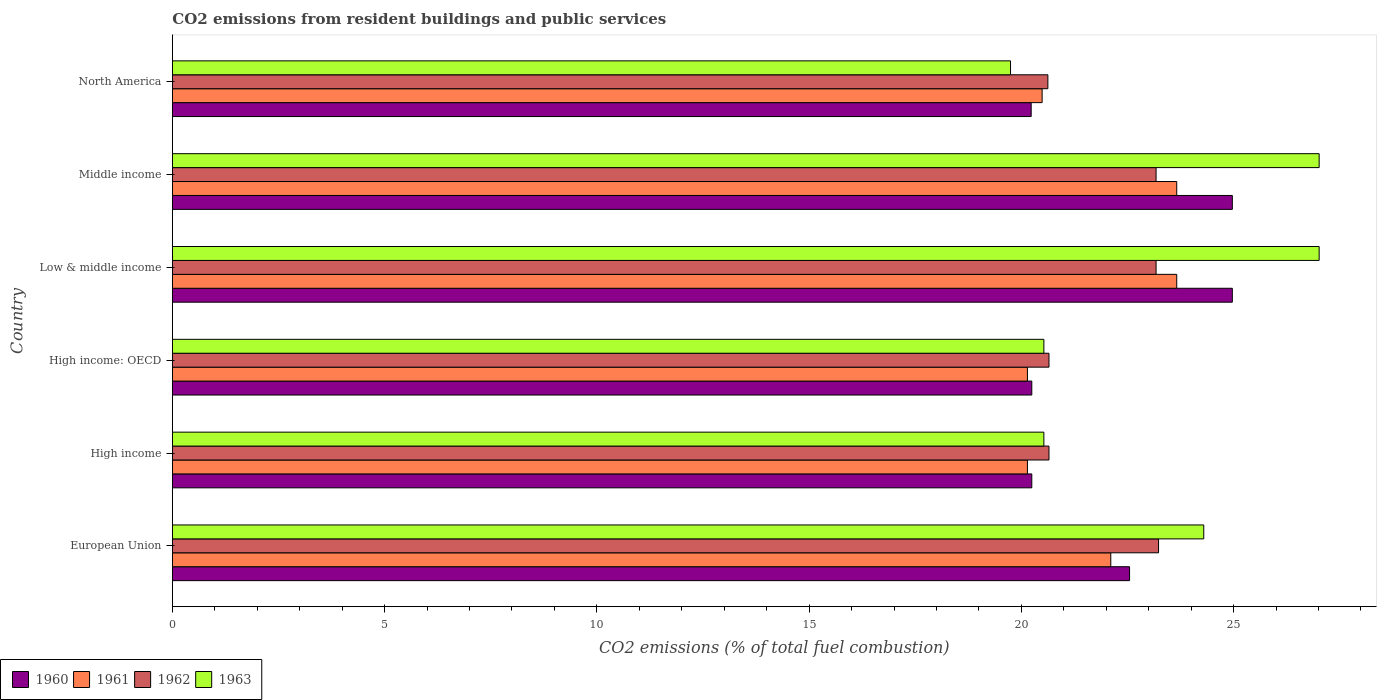How many groups of bars are there?
Make the answer very short. 6. Are the number of bars per tick equal to the number of legend labels?
Ensure brevity in your answer.  Yes. Are the number of bars on each tick of the Y-axis equal?
Provide a succinct answer. Yes. How many bars are there on the 1st tick from the top?
Provide a succinct answer. 4. What is the total CO2 emitted in 1962 in High income: OECD?
Offer a terse response. 20.65. Across all countries, what is the maximum total CO2 emitted in 1962?
Provide a short and direct response. 23.23. Across all countries, what is the minimum total CO2 emitted in 1960?
Your response must be concise. 20.23. What is the total total CO2 emitted in 1963 in the graph?
Give a very brief answer. 139.13. What is the difference between the total CO2 emitted in 1961 in European Union and that in North America?
Make the answer very short. 1.62. What is the difference between the total CO2 emitted in 1960 in North America and the total CO2 emitted in 1962 in Low & middle income?
Your answer should be compact. -2.94. What is the average total CO2 emitted in 1963 per country?
Offer a terse response. 23.19. What is the difference between the total CO2 emitted in 1960 and total CO2 emitted in 1961 in Low & middle income?
Keep it short and to the point. 1.31. Is the total CO2 emitted in 1960 in European Union less than that in High income?
Ensure brevity in your answer.  No. Is the difference between the total CO2 emitted in 1960 in European Union and High income greater than the difference between the total CO2 emitted in 1961 in European Union and High income?
Offer a very short reply. Yes. What is the difference between the highest and the second highest total CO2 emitted in 1960?
Ensure brevity in your answer.  0. What is the difference between the highest and the lowest total CO2 emitted in 1963?
Offer a very short reply. 7.27. Is it the case that in every country, the sum of the total CO2 emitted in 1961 and total CO2 emitted in 1963 is greater than the sum of total CO2 emitted in 1962 and total CO2 emitted in 1960?
Your answer should be very brief. No. What does the 1st bar from the bottom in Low & middle income represents?
Your answer should be very brief. 1960. How many bars are there?
Give a very brief answer. 24. Are all the bars in the graph horizontal?
Ensure brevity in your answer.  Yes. How many countries are there in the graph?
Your answer should be compact. 6. Are the values on the major ticks of X-axis written in scientific E-notation?
Ensure brevity in your answer.  No. How many legend labels are there?
Your response must be concise. 4. How are the legend labels stacked?
Provide a short and direct response. Horizontal. What is the title of the graph?
Keep it short and to the point. CO2 emissions from resident buildings and public services. Does "2001" appear as one of the legend labels in the graph?
Offer a terse response. No. What is the label or title of the X-axis?
Provide a short and direct response. CO2 emissions (% of total fuel combustion). What is the label or title of the Y-axis?
Make the answer very short. Country. What is the CO2 emissions (% of total fuel combustion) in 1960 in European Union?
Ensure brevity in your answer.  22.55. What is the CO2 emissions (% of total fuel combustion) of 1961 in European Union?
Your answer should be very brief. 22.11. What is the CO2 emissions (% of total fuel combustion) in 1962 in European Union?
Keep it short and to the point. 23.23. What is the CO2 emissions (% of total fuel combustion) of 1963 in European Union?
Offer a very short reply. 24.3. What is the CO2 emissions (% of total fuel combustion) in 1960 in High income?
Your answer should be compact. 20.25. What is the CO2 emissions (% of total fuel combustion) in 1961 in High income?
Make the answer very short. 20.14. What is the CO2 emissions (% of total fuel combustion) in 1962 in High income?
Your response must be concise. 20.65. What is the CO2 emissions (% of total fuel combustion) in 1963 in High income?
Give a very brief answer. 20.53. What is the CO2 emissions (% of total fuel combustion) in 1960 in High income: OECD?
Your answer should be very brief. 20.25. What is the CO2 emissions (% of total fuel combustion) in 1961 in High income: OECD?
Ensure brevity in your answer.  20.14. What is the CO2 emissions (% of total fuel combustion) in 1962 in High income: OECD?
Your answer should be compact. 20.65. What is the CO2 emissions (% of total fuel combustion) in 1963 in High income: OECD?
Your answer should be compact. 20.53. What is the CO2 emissions (% of total fuel combustion) of 1960 in Low & middle income?
Make the answer very short. 24.97. What is the CO2 emissions (% of total fuel combustion) of 1961 in Low & middle income?
Provide a succinct answer. 23.66. What is the CO2 emissions (% of total fuel combustion) of 1962 in Low & middle income?
Ensure brevity in your answer.  23.17. What is the CO2 emissions (% of total fuel combustion) in 1963 in Low & middle income?
Ensure brevity in your answer.  27.01. What is the CO2 emissions (% of total fuel combustion) of 1960 in Middle income?
Offer a terse response. 24.97. What is the CO2 emissions (% of total fuel combustion) in 1961 in Middle income?
Your answer should be compact. 23.66. What is the CO2 emissions (% of total fuel combustion) in 1962 in Middle income?
Offer a terse response. 23.17. What is the CO2 emissions (% of total fuel combustion) in 1963 in Middle income?
Your answer should be compact. 27.01. What is the CO2 emissions (% of total fuel combustion) in 1960 in North America?
Provide a short and direct response. 20.23. What is the CO2 emissions (% of total fuel combustion) in 1961 in North America?
Your response must be concise. 20.49. What is the CO2 emissions (% of total fuel combustion) of 1962 in North America?
Offer a terse response. 20.62. What is the CO2 emissions (% of total fuel combustion) in 1963 in North America?
Ensure brevity in your answer.  19.74. Across all countries, what is the maximum CO2 emissions (% of total fuel combustion) in 1960?
Ensure brevity in your answer.  24.97. Across all countries, what is the maximum CO2 emissions (% of total fuel combustion) of 1961?
Give a very brief answer. 23.66. Across all countries, what is the maximum CO2 emissions (% of total fuel combustion) of 1962?
Keep it short and to the point. 23.23. Across all countries, what is the maximum CO2 emissions (% of total fuel combustion) of 1963?
Offer a terse response. 27.01. Across all countries, what is the minimum CO2 emissions (% of total fuel combustion) of 1960?
Keep it short and to the point. 20.23. Across all countries, what is the minimum CO2 emissions (% of total fuel combustion) in 1961?
Your response must be concise. 20.14. Across all countries, what is the minimum CO2 emissions (% of total fuel combustion) in 1962?
Your answer should be very brief. 20.62. Across all countries, what is the minimum CO2 emissions (% of total fuel combustion) in 1963?
Your answer should be very brief. 19.74. What is the total CO2 emissions (% of total fuel combustion) in 1960 in the graph?
Keep it short and to the point. 133.21. What is the total CO2 emissions (% of total fuel combustion) in 1961 in the graph?
Ensure brevity in your answer.  130.2. What is the total CO2 emissions (% of total fuel combustion) in 1962 in the graph?
Make the answer very short. 131.5. What is the total CO2 emissions (% of total fuel combustion) in 1963 in the graph?
Offer a terse response. 139.13. What is the difference between the CO2 emissions (% of total fuel combustion) in 1960 in European Union and that in High income?
Your response must be concise. 2.3. What is the difference between the CO2 emissions (% of total fuel combustion) in 1961 in European Union and that in High income?
Offer a terse response. 1.96. What is the difference between the CO2 emissions (% of total fuel combustion) in 1962 in European Union and that in High income?
Offer a terse response. 2.58. What is the difference between the CO2 emissions (% of total fuel combustion) in 1963 in European Union and that in High income?
Offer a very short reply. 3.77. What is the difference between the CO2 emissions (% of total fuel combustion) of 1960 in European Union and that in High income: OECD?
Your answer should be compact. 2.3. What is the difference between the CO2 emissions (% of total fuel combustion) in 1961 in European Union and that in High income: OECD?
Your response must be concise. 1.96. What is the difference between the CO2 emissions (% of total fuel combustion) in 1962 in European Union and that in High income: OECD?
Your answer should be compact. 2.58. What is the difference between the CO2 emissions (% of total fuel combustion) in 1963 in European Union and that in High income: OECD?
Offer a very short reply. 3.77. What is the difference between the CO2 emissions (% of total fuel combustion) of 1960 in European Union and that in Low & middle income?
Your response must be concise. -2.42. What is the difference between the CO2 emissions (% of total fuel combustion) of 1961 in European Union and that in Low & middle income?
Provide a short and direct response. -1.55. What is the difference between the CO2 emissions (% of total fuel combustion) of 1962 in European Union and that in Low & middle income?
Your answer should be very brief. 0.06. What is the difference between the CO2 emissions (% of total fuel combustion) in 1963 in European Union and that in Low & middle income?
Your answer should be very brief. -2.72. What is the difference between the CO2 emissions (% of total fuel combustion) of 1960 in European Union and that in Middle income?
Your response must be concise. -2.42. What is the difference between the CO2 emissions (% of total fuel combustion) of 1961 in European Union and that in Middle income?
Your answer should be compact. -1.55. What is the difference between the CO2 emissions (% of total fuel combustion) in 1962 in European Union and that in Middle income?
Offer a terse response. 0.06. What is the difference between the CO2 emissions (% of total fuel combustion) in 1963 in European Union and that in Middle income?
Provide a short and direct response. -2.72. What is the difference between the CO2 emissions (% of total fuel combustion) in 1960 in European Union and that in North America?
Offer a terse response. 2.32. What is the difference between the CO2 emissions (% of total fuel combustion) in 1961 in European Union and that in North America?
Make the answer very short. 1.62. What is the difference between the CO2 emissions (% of total fuel combustion) of 1962 in European Union and that in North America?
Offer a terse response. 2.61. What is the difference between the CO2 emissions (% of total fuel combustion) of 1963 in European Union and that in North America?
Provide a short and direct response. 4.55. What is the difference between the CO2 emissions (% of total fuel combustion) of 1960 in High income and that in High income: OECD?
Provide a short and direct response. 0. What is the difference between the CO2 emissions (% of total fuel combustion) in 1960 in High income and that in Low & middle income?
Provide a short and direct response. -4.72. What is the difference between the CO2 emissions (% of total fuel combustion) in 1961 in High income and that in Low & middle income?
Ensure brevity in your answer.  -3.52. What is the difference between the CO2 emissions (% of total fuel combustion) of 1962 in High income and that in Low & middle income?
Provide a short and direct response. -2.52. What is the difference between the CO2 emissions (% of total fuel combustion) of 1963 in High income and that in Low & middle income?
Provide a short and direct response. -6.48. What is the difference between the CO2 emissions (% of total fuel combustion) in 1960 in High income and that in Middle income?
Make the answer very short. -4.72. What is the difference between the CO2 emissions (% of total fuel combustion) of 1961 in High income and that in Middle income?
Make the answer very short. -3.52. What is the difference between the CO2 emissions (% of total fuel combustion) of 1962 in High income and that in Middle income?
Your response must be concise. -2.52. What is the difference between the CO2 emissions (% of total fuel combustion) in 1963 in High income and that in Middle income?
Your answer should be compact. -6.48. What is the difference between the CO2 emissions (% of total fuel combustion) in 1960 in High income and that in North America?
Your answer should be compact. 0.01. What is the difference between the CO2 emissions (% of total fuel combustion) of 1961 in High income and that in North America?
Offer a terse response. -0.35. What is the difference between the CO2 emissions (% of total fuel combustion) of 1962 in High income and that in North America?
Provide a short and direct response. 0.03. What is the difference between the CO2 emissions (% of total fuel combustion) of 1963 in High income and that in North America?
Provide a succinct answer. 0.79. What is the difference between the CO2 emissions (% of total fuel combustion) of 1960 in High income: OECD and that in Low & middle income?
Your answer should be very brief. -4.72. What is the difference between the CO2 emissions (% of total fuel combustion) of 1961 in High income: OECD and that in Low & middle income?
Ensure brevity in your answer.  -3.52. What is the difference between the CO2 emissions (% of total fuel combustion) in 1962 in High income: OECD and that in Low & middle income?
Provide a short and direct response. -2.52. What is the difference between the CO2 emissions (% of total fuel combustion) in 1963 in High income: OECD and that in Low & middle income?
Your response must be concise. -6.48. What is the difference between the CO2 emissions (% of total fuel combustion) in 1960 in High income: OECD and that in Middle income?
Ensure brevity in your answer.  -4.72. What is the difference between the CO2 emissions (% of total fuel combustion) in 1961 in High income: OECD and that in Middle income?
Your answer should be very brief. -3.52. What is the difference between the CO2 emissions (% of total fuel combustion) in 1962 in High income: OECD and that in Middle income?
Your answer should be compact. -2.52. What is the difference between the CO2 emissions (% of total fuel combustion) in 1963 in High income: OECD and that in Middle income?
Provide a succinct answer. -6.48. What is the difference between the CO2 emissions (% of total fuel combustion) in 1960 in High income: OECD and that in North America?
Your answer should be compact. 0.01. What is the difference between the CO2 emissions (% of total fuel combustion) of 1961 in High income: OECD and that in North America?
Your response must be concise. -0.35. What is the difference between the CO2 emissions (% of total fuel combustion) of 1962 in High income: OECD and that in North America?
Offer a very short reply. 0.03. What is the difference between the CO2 emissions (% of total fuel combustion) of 1963 in High income: OECD and that in North America?
Your response must be concise. 0.79. What is the difference between the CO2 emissions (% of total fuel combustion) in 1960 in Low & middle income and that in Middle income?
Your response must be concise. 0. What is the difference between the CO2 emissions (% of total fuel combustion) in 1960 in Low & middle income and that in North America?
Make the answer very short. 4.74. What is the difference between the CO2 emissions (% of total fuel combustion) in 1961 in Low & middle income and that in North America?
Offer a terse response. 3.17. What is the difference between the CO2 emissions (% of total fuel combustion) in 1962 in Low & middle income and that in North America?
Offer a very short reply. 2.55. What is the difference between the CO2 emissions (% of total fuel combustion) in 1963 in Low & middle income and that in North America?
Your response must be concise. 7.27. What is the difference between the CO2 emissions (% of total fuel combustion) of 1960 in Middle income and that in North America?
Make the answer very short. 4.74. What is the difference between the CO2 emissions (% of total fuel combustion) of 1961 in Middle income and that in North America?
Offer a terse response. 3.17. What is the difference between the CO2 emissions (% of total fuel combustion) in 1962 in Middle income and that in North America?
Your response must be concise. 2.55. What is the difference between the CO2 emissions (% of total fuel combustion) of 1963 in Middle income and that in North America?
Give a very brief answer. 7.27. What is the difference between the CO2 emissions (% of total fuel combustion) in 1960 in European Union and the CO2 emissions (% of total fuel combustion) in 1961 in High income?
Your response must be concise. 2.41. What is the difference between the CO2 emissions (% of total fuel combustion) of 1960 in European Union and the CO2 emissions (% of total fuel combustion) of 1962 in High income?
Provide a succinct answer. 1.9. What is the difference between the CO2 emissions (% of total fuel combustion) in 1960 in European Union and the CO2 emissions (% of total fuel combustion) in 1963 in High income?
Your response must be concise. 2.02. What is the difference between the CO2 emissions (% of total fuel combustion) in 1961 in European Union and the CO2 emissions (% of total fuel combustion) in 1962 in High income?
Provide a short and direct response. 1.46. What is the difference between the CO2 emissions (% of total fuel combustion) in 1961 in European Union and the CO2 emissions (% of total fuel combustion) in 1963 in High income?
Give a very brief answer. 1.58. What is the difference between the CO2 emissions (% of total fuel combustion) of 1962 in European Union and the CO2 emissions (% of total fuel combustion) of 1963 in High income?
Offer a very short reply. 2.7. What is the difference between the CO2 emissions (% of total fuel combustion) in 1960 in European Union and the CO2 emissions (% of total fuel combustion) in 1961 in High income: OECD?
Make the answer very short. 2.41. What is the difference between the CO2 emissions (% of total fuel combustion) of 1960 in European Union and the CO2 emissions (% of total fuel combustion) of 1962 in High income: OECD?
Your answer should be compact. 1.9. What is the difference between the CO2 emissions (% of total fuel combustion) of 1960 in European Union and the CO2 emissions (% of total fuel combustion) of 1963 in High income: OECD?
Provide a succinct answer. 2.02. What is the difference between the CO2 emissions (% of total fuel combustion) of 1961 in European Union and the CO2 emissions (% of total fuel combustion) of 1962 in High income: OECD?
Your response must be concise. 1.46. What is the difference between the CO2 emissions (% of total fuel combustion) of 1961 in European Union and the CO2 emissions (% of total fuel combustion) of 1963 in High income: OECD?
Provide a succinct answer. 1.58. What is the difference between the CO2 emissions (% of total fuel combustion) of 1962 in European Union and the CO2 emissions (% of total fuel combustion) of 1963 in High income: OECD?
Make the answer very short. 2.7. What is the difference between the CO2 emissions (% of total fuel combustion) in 1960 in European Union and the CO2 emissions (% of total fuel combustion) in 1961 in Low & middle income?
Your answer should be compact. -1.11. What is the difference between the CO2 emissions (% of total fuel combustion) in 1960 in European Union and the CO2 emissions (% of total fuel combustion) in 1962 in Low & middle income?
Your answer should be compact. -0.62. What is the difference between the CO2 emissions (% of total fuel combustion) of 1960 in European Union and the CO2 emissions (% of total fuel combustion) of 1963 in Low & middle income?
Offer a terse response. -4.47. What is the difference between the CO2 emissions (% of total fuel combustion) of 1961 in European Union and the CO2 emissions (% of total fuel combustion) of 1962 in Low & middle income?
Ensure brevity in your answer.  -1.07. What is the difference between the CO2 emissions (% of total fuel combustion) in 1961 in European Union and the CO2 emissions (% of total fuel combustion) in 1963 in Low & middle income?
Provide a succinct answer. -4.91. What is the difference between the CO2 emissions (% of total fuel combustion) of 1962 in European Union and the CO2 emissions (% of total fuel combustion) of 1963 in Low & middle income?
Give a very brief answer. -3.78. What is the difference between the CO2 emissions (% of total fuel combustion) in 1960 in European Union and the CO2 emissions (% of total fuel combustion) in 1961 in Middle income?
Your answer should be very brief. -1.11. What is the difference between the CO2 emissions (% of total fuel combustion) in 1960 in European Union and the CO2 emissions (% of total fuel combustion) in 1962 in Middle income?
Your answer should be very brief. -0.62. What is the difference between the CO2 emissions (% of total fuel combustion) in 1960 in European Union and the CO2 emissions (% of total fuel combustion) in 1963 in Middle income?
Provide a short and direct response. -4.47. What is the difference between the CO2 emissions (% of total fuel combustion) of 1961 in European Union and the CO2 emissions (% of total fuel combustion) of 1962 in Middle income?
Offer a terse response. -1.07. What is the difference between the CO2 emissions (% of total fuel combustion) of 1961 in European Union and the CO2 emissions (% of total fuel combustion) of 1963 in Middle income?
Provide a succinct answer. -4.91. What is the difference between the CO2 emissions (% of total fuel combustion) in 1962 in European Union and the CO2 emissions (% of total fuel combustion) in 1963 in Middle income?
Offer a very short reply. -3.78. What is the difference between the CO2 emissions (% of total fuel combustion) in 1960 in European Union and the CO2 emissions (% of total fuel combustion) in 1961 in North America?
Give a very brief answer. 2.06. What is the difference between the CO2 emissions (% of total fuel combustion) of 1960 in European Union and the CO2 emissions (% of total fuel combustion) of 1962 in North America?
Ensure brevity in your answer.  1.92. What is the difference between the CO2 emissions (% of total fuel combustion) in 1960 in European Union and the CO2 emissions (% of total fuel combustion) in 1963 in North America?
Your response must be concise. 2.8. What is the difference between the CO2 emissions (% of total fuel combustion) in 1961 in European Union and the CO2 emissions (% of total fuel combustion) in 1962 in North America?
Offer a very short reply. 1.48. What is the difference between the CO2 emissions (% of total fuel combustion) of 1961 in European Union and the CO2 emissions (% of total fuel combustion) of 1963 in North America?
Offer a terse response. 2.36. What is the difference between the CO2 emissions (% of total fuel combustion) of 1962 in European Union and the CO2 emissions (% of total fuel combustion) of 1963 in North America?
Your answer should be compact. 3.49. What is the difference between the CO2 emissions (% of total fuel combustion) in 1960 in High income and the CO2 emissions (% of total fuel combustion) in 1961 in High income: OECD?
Ensure brevity in your answer.  0.1. What is the difference between the CO2 emissions (% of total fuel combustion) of 1960 in High income and the CO2 emissions (% of total fuel combustion) of 1962 in High income: OECD?
Your answer should be very brief. -0.4. What is the difference between the CO2 emissions (% of total fuel combustion) of 1960 in High income and the CO2 emissions (% of total fuel combustion) of 1963 in High income: OECD?
Your answer should be very brief. -0.28. What is the difference between the CO2 emissions (% of total fuel combustion) in 1961 in High income and the CO2 emissions (% of total fuel combustion) in 1962 in High income: OECD?
Make the answer very short. -0.51. What is the difference between the CO2 emissions (% of total fuel combustion) in 1961 in High income and the CO2 emissions (% of total fuel combustion) in 1963 in High income: OECD?
Offer a very short reply. -0.39. What is the difference between the CO2 emissions (% of total fuel combustion) of 1962 in High income and the CO2 emissions (% of total fuel combustion) of 1963 in High income: OECD?
Provide a succinct answer. 0.12. What is the difference between the CO2 emissions (% of total fuel combustion) in 1960 in High income and the CO2 emissions (% of total fuel combustion) in 1961 in Low & middle income?
Provide a succinct answer. -3.41. What is the difference between the CO2 emissions (% of total fuel combustion) in 1960 in High income and the CO2 emissions (% of total fuel combustion) in 1962 in Low & middle income?
Make the answer very short. -2.93. What is the difference between the CO2 emissions (% of total fuel combustion) of 1960 in High income and the CO2 emissions (% of total fuel combustion) of 1963 in Low & middle income?
Offer a terse response. -6.77. What is the difference between the CO2 emissions (% of total fuel combustion) of 1961 in High income and the CO2 emissions (% of total fuel combustion) of 1962 in Low & middle income?
Give a very brief answer. -3.03. What is the difference between the CO2 emissions (% of total fuel combustion) of 1961 in High income and the CO2 emissions (% of total fuel combustion) of 1963 in Low & middle income?
Offer a terse response. -6.87. What is the difference between the CO2 emissions (% of total fuel combustion) in 1962 in High income and the CO2 emissions (% of total fuel combustion) in 1963 in Low & middle income?
Make the answer very short. -6.36. What is the difference between the CO2 emissions (% of total fuel combustion) in 1960 in High income and the CO2 emissions (% of total fuel combustion) in 1961 in Middle income?
Ensure brevity in your answer.  -3.41. What is the difference between the CO2 emissions (% of total fuel combustion) in 1960 in High income and the CO2 emissions (% of total fuel combustion) in 1962 in Middle income?
Your response must be concise. -2.93. What is the difference between the CO2 emissions (% of total fuel combustion) of 1960 in High income and the CO2 emissions (% of total fuel combustion) of 1963 in Middle income?
Offer a terse response. -6.77. What is the difference between the CO2 emissions (% of total fuel combustion) of 1961 in High income and the CO2 emissions (% of total fuel combustion) of 1962 in Middle income?
Offer a terse response. -3.03. What is the difference between the CO2 emissions (% of total fuel combustion) of 1961 in High income and the CO2 emissions (% of total fuel combustion) of 1963 in Middle income?
Give a very brief answer. -6.87. What is the difference between the CO2 emissions (% of total fuel combustion) in 1962 in High income and the CO2 emissions (% of total fuel combustion) in 1963 in Middle income?
Provide a short and direct response. -6.36. What is the difference between the CO2 emissions (% of total fuel combustion) of 1960 in High income and the CO2 emissions (% of total fuel combustion) of 1961 in North America?
Your answer should be compact. -0.24. What is the difference between the CO2 emissions (% of total fuel combustion) in 1960 in High income and the CO2 emissions (% of total fuel combustion) in 1962 in North America?
Provide a succinct answer. -0.38. What is the difference between the CO2 emissions (% of total fuel combustion) of 1960 in High income and the CO2 emissions (% of total fuel combustion) of 1963 in North America?
Give a very brief answer. 0.5. What is the difference between the CO2 emissions (% of total fuel combustion) in 1961 in High income and the CO2 emissions (% of total fuel combustion) in 1962 in North America?
Give a very brief answer. -0.48. What is the difference between the CO2 emissions (% of total fuel combustion) of 1961 in High income and the CO2 emissions (% of total fuel combustion) of 1963 in North America?
Provide a short and direct response. 0.4. What is the difference between the CO2 emissions (% of total fuel combustion) of 1962 in High income and the CO2 emissions (% of total fuel combustion) of 1963 in North America?
Your response must be concise. 0.91. What is the difference between the CO2 emissions (% of total fuel combustion) in 1960 in High income: OECD and the CO2 emissions (% of total fuel combustion) in 1961 in Low & middle income?
Keep it short and to the point. -3.41. What is the difference between the CO2 emissions (% of total fuel combustion) of 1960 in High income: OECD and the CO2 emissions (% of total fuel combustion) of 1962 in Low & middle income?
Provide a short and direct response. -2.93. What is the difference between the CO2 emissions (% of total fuel combustion) in 1960 in High income: OECD and the CO2 emissions (% of total fuel combustion) in 1963 in Low & middle income?
Your answer should be compact. -6.77. What is the difference between the CO2 emissions (% of total fuel combustion) in 1961 in High income: OECD and the CO2 emissions (% of total fuel combustion) in 1962 in Low & middle income?
Your answer should be compact. -3.03. What is the difference between the CO2 emissions (% of total fuel combustion) in 1961 in High income: OECD and the CO2 emissions (% of total fuel combustion) in 1963 in Low & middle income?
Offer a terse response. -6.87. What is the difference between the CO2 emissions (% of total fuel combustion) in 1962 in High income: OECD and the CO2 emissions (% of total fuel combustion) in 1963 in Low & middle income?
Provide a succinct answer. -6.36. What is the difference between the CO2 emissions (% of total fuel combustion) in 1960 in High income: OECD and the CO2 emissions (% of total fuel combustion) in 1961 in Middle income?
Your answer should be compact. -3.41. What is the difference between the CO2 emissions (% of total fuel combustion) in 1960 in High income: OECD and the CO2 emissions (% of total fuel combustion) in 1962 in Middle income?
Offer a very short reply. -2.93. What is the difference between the CO2 emissions (% of total fuel combustion) of 1960 in High income: OECD and the CO2 emissions (% of total fuel combustion) of 1963 in Middle income?
Your response must be concise. -6.77. What is the difference between the CO2 emissions (% of total fuel combustion) in 1961 in High income: OECD and the CO2 emissions (% of total fuel combustion) in 1962 in Middle income?
Your answer should be very brief. -3.03. What is the difference between the CO2 emissions (% of total fuel combustion) of 1961 in High income: OECD and the CO2 emissions (% of total fuel combustion) of 1963 in Middle income?
Provide a succinct answer. -6.87. What is the difference between the CO2 emissions (% of total fuel combustion) of 1962 in High income: OECD and the CO2 emissions (% of total fuel combustion) of 1963 in Middle income?
Provide a succinct answer. -6.36. What is the difference between the CO2 emissions (% of total fuel combustion) of 1960 in High income: OECD and the CO2 emissions (% of total fuel combustion) of 1961 in North America?
Offer a terse response. -0.24. What is the difference between the CO2 emissions (% of total fuel combustion) in 1960 in High income: OECD and the CO2 emissions (% of total fuel combustion) in 1962 in North America?
Offer a terse response. -0.38. What is the difference between the CO2 emissions (% of total fuel combustion) of 1960 in High income: OECD and the CO2 emissions (% of total fuel combustion) of 1963 in North America?
Keep it short and to the point. 0.5. What is the difference between the CO2 emissions (% of total fuel combustion) in 1961 in High income: OECD and the CO2 emissions (% of total fuel combustion) in 1962 in North America?
Your response must be concise. -0.48. What is the difference between the CO2 emissions (% of total fuel combustion) of 1961 in High income: OECD and the CO2 emissions (% of total fuel combustion) of 1963 in North America?
Your response must be concise. 0.4. What is the difference between the CO2 emissions (% of total fuel combustion) in 1962 in High income: OECD and the CO2 emissions (% of total fuel combustion) in 1963 in North America?
Offer a very short reply. 0.91. What is the difference between the CO2 emissions (% of total fuel combustion) of 1960 in Low & middle income and the CO2 emissions (% of total fuel combustion) of 1961 in Middle income?
Keep it short and to the point. 1.31. What is the difference between the CO2 emissions (% of total fuel combustion) in 1960 in Low & middle income and the CO2 emissions (% of total fuel combustion) in 1962 in Middle income?
Ensure brevity in your answer.  1.8. What is the difference between the CO2 emissions (% of total fuel combustion) of 1960 in Low & middle income and the CO2 emissions (% of total fuel combustion) of 1963 in Middle income?
Provide a short and direct response. -2.05. What is the difference between the CO2 emissions (% of total fuel combustion) of 1961 in Low & middle income and the CO2 emissions (% of total fuel combustion) of 1962 in Middle income?
Provide a succinct answer. 0.49. What is the difference between the CO2 emissions (% of total fuel combustion) of 1961 in Low & middle income and the CO2 emissions (% of total fuel combustion) of 1963 in Middle income?
Your response must be concise. -3.35. What is the difference between the CO2 emissions (% of total fuel combustion) in 1962 in Low & middle income and the CO2 emissions (% of total fuel combustion) in 1963 in Middle income?
Your answer should be very brief. -3.84. What is the difference between the CO2 emissions (% of total fuel combustion) in 1960 in Low & middle income and the CO2 emissions (% of total fuel combustion) in 1961 in North America?
Your answer should be compact. 4.48. What is the difference between the CO2 emissions (% of total fuel combustion) in 1960 in Low & middle income and the CO2 emissions (% of total fuel combustion) in 1962 in North America?
Offer a very short reply. 4.35. What is the difference between the CO2 emissions (% of total fuel combustion) of 1960 in Low & middle income and the CO2 emissions (% of total fuel combustion) of 1963 in North America?
Make the answer very short. 5.22. What is the difference between the CO2 emissions (% of total fuel combustion) of 1961 in Low & middle income and the CO2 emissions (% of total fuel combustion) of 1962 in North America?
Offer a terse response. 3.04. What is the difference between the CO2 emissions (% of total fuel combustion) in 1961 in Low & middle income and the CO2 emissions (% of total fuel combustion) in 1963 in North America?
Provide a succinct answer. 3.92. What is the difference between the CO2 emissions (% of total fuel combustion) in 1962 in Low & middle income and the CO2 emissions (% of total fuel combustion) in 1963 in North America?
Your response must be concise. 3.43. What is the difference between the CO2 emissions (% of total fuel combustion) in 1960 in Middle income and the CO2 emissions (% of total fuel combustion) in 1961 in North America?
Your response must be concise. 4.48. What is the difference between the CO2 emissions (% of total fuel combustion) in 1960 in Middle income and the CO2 emissions (% of total fuel combustion) in 1962 in North America?
Your answer should be very brief. 4.35. What is the difference between the CO2 emissions (% of total fuel combustion) of 1960 in Middle income and the CO2 emissions (% of total fuel combustion) of 1963 in North America?
Make the answer very short. 5.22. What is the difference between the CO2 emissions (% of total fuel combustion) in 1961 in Middle income and the CO2 emissions (% of total fuel combustion) in 1962 in North America?
Ensure brevity in your answer.  3.04. What is the difference between the CO2 emissions (% of total fuel combustion) of 1961 in Middle income and the CO2 emissions (% of total fuel combustion) of 1963 in North America?
Make the answer very short. 3.92. What is the difference between the CO2 emissions (% of total fuel combustion) in 1962 in Middle income and the CO2 emissions (% of total fuel combustion) in 1963 in North America?
Keep it short and to the point. 3.43. What is the average CO2 emissions (% of total fuel combustion) of 1960 per country?
Your response must be concise. 22.2. What is the average CO2 emissions (% of total fuel combustion) in 1961 per country?
Offer a very short reply. 21.7. What is the average CO2 emissions (% of total fuel combustion) in 1962 per country?
Ensure brevity in your answer.  21.92. What is the average CO2 emissions (% of total fuel combustion) in 1963 per country?
Your answer should be very brief. 23.19. What is the difference between the CO2 emissions (% of total fuel combustion) in 1960 and CO2 emissions (% of total fuel combustion) in 1961 in European Union?
Your response must be concise. 0.44. What is the difference between the CO2 emissions (% of total fuel combustion) in 1960 and CO2 emissions (% of total fuel combustion) in 1962 in European Union?
Provide a succinct answer. -0.68. What is the difference between the CO2 emissions (% of total fuel combustion) in 1960 and CO2 emissions (% of total fuel combustion) in 1963 in European Union?
Your answer should be very brief. -1.75. What is the difference between the CO2 emissions (% of total fuel combustion) of 1961 and CO2 emissions (% of total fuel combustion) of 1962 in European Union?
Give a very brief answer. -1.13. What is the difference between the CO2 emissions (% of total fuel combustion) in 1961 and CO2 emissions (% of total fuel combustion) in 1963 in European Union?
Make the answer very short. -2.19. What is the difference between the CO2 emissions (% of total fuel combustion) of 1962 and CO2 emissions (% of total fuel combustion) of 1963 in European Union?
Your answer should be very brief. -1.07. What is the difference between the CO2 emissions (% of total fuel combustion) of 1960 and CO2 emissions (% of total fuel combustion) of 1961 in High income?
Provide a short and direct response. 0.1. What is the difference between the CO2 emissions (% of total fuel combustion) in 1960 and CO2 emissions (% of total fuel combustion) in 1962 in High income?
Provide a short and direct response. -0.4. What is the difference between the CO2 emissions (% of total fuel combustion) in 1960 and CO2 emissions (% of total fuel combustion) in 1963 in High income?
Ensure brevity in your answer.  -0.28. What is the difference between the CO2 emissions (% of total fuel combustion) in 1961 and CO2 emissions (% of total fuel combustion) in 1962 in High income?
Offer a very short reply. -0.51. What is the difference between the CO2 emissions (% of total fuel combustion) of 1961 and CO2 emissions (% of total fuel combustion) of 1963 in High income?
Keep it short and to the point. -0.39. What is the difference between the CO2 emissions (% of total fuel combustion) in 1962 and CO2 emissions (% of total fuel combustion) in 1963 in High income?
Provide a succinct answer. 0.12. What is the difference between the CO2 emissions (% of total fuel combustion) of 1960 and CO2 emissions (% of total fuel combustion) of 1961 in High income: OECD?
Keep it short and to the point. 0.1. What is the difference between the CO2 emissions (% of total fuel combustion) of 1960 and CO2 emissions (% of total fuel combustion) of 1962 in High income: OECD?
Provide a succinct answer. -0.4. What is the difference between the CO2 emissions (% of total fuel combustion) of 1960 and CO2 emissions (% of total fuel combustion) of 1963 in High income: OECD?
Your answer should be compact. -0.28. What is the difference between the CO2 emissions (% of total fuel combustion) in 1961 and CO2 emissions (% of total fuel combustion) in 1962 in High income: OECD?
Ensure brevity in your answer.  -0.51. What is the difference between the CO2 emissions (% of total fuel combustion) of 1961 and CO2 emissions (% of total fuel combustion) of 1963 in High income: OECD?
Provide a succinct answer. -0.39. What is the difference between the CO2 emissions (% of total fuel combustion) in 1962 and CO2 emissions (% of total fuel combustion) in 1963 in High income: OECD?
Your response must be concise. 0.12. What is the difference between the CO2 emissions (% of total fuel combustion) in 1960 and CO2 emissions (% of total fuel combustion) in 1961 in Low & middle income?
Your answer should be very brief. 1.31. What is the difference between the CO2 emissions (% of total fuel combustion) in 1960 and CO2 emissions (% of total fuel combustion) in 1962 in Low & middle income?
Provide a short and direct response. 1.8. What is the difference between the CO2 emissions (% of total fuel combustion) in 1960 and CO2 emissions (% of total fuel combustion) in 1963 in Low & middle income?
Provide a short and direct response. -2.05. What is the difference between the CO2 emissions (% of total fuel combustion) of 1961 and CO2 emissions (% of total fuel combustion) of 1962 in Low & middle income?
Ensure brevity in your answer.  0.49. What is the difference between the CO2 emissions (% of total fuel combustion) in 1961 and CO2 emissions (% of total fuel combustion) in 1963 in Low & middle income?
Provide a short and direct response. -3.35. What is the difference between the CO2 emissions (% of total fuel combustion) in 1962 and CO2 emissions (% of total fuel combustion) in 1963 in Low & middle income?
Ensure brevity in your answer.  -3.84. What is the difference between the CO2 emissions (% of total fuel combustion) in 1960 and CO2 emissions (% of total fuel combustion) in 1961 in Middle income?
Your answer should be very brief. 1.31. What is the difference between the CO2 emissions (% of total fuel combustion) of 1960 and CO2 emissions (% of total fuel combustion) of 1962 in Middle income?
Your response must be concise. 1.8. What is the difference between the CO2 emissions (% of total fuel combustion) of 1960 and CO2 emissions (% of total fuel combustion) of 1963 in Middle income?
Provide a short and direct response. -2.05. What is the difference between the CO2 emissions (% of total fuel combustion) of 1961 and CO2 emissions (% of total fuel combustion) of 1962 in Middle income?
Give a very brief answer. 0.49. What is the difference between the CO2 emissions (% of total fuel combustion) of 1961 and CO2 emissions (% of total fuel combustion) of 1963 in Middle income?
Provide a short and direct response. -3.35. What is the difference between the CO2 emissions (% of total fuel combustion) of 1962 and CO2 emissions (% of total fuel combustion) of 1963 in Middle income?
Your response must be concise. -3.84. What is the difference between the CO2 emissions (% of total fuel combustion) in 1960 and CO2 emissions (% of total fuel combustion) in 1961 in North America?
Offer a terse response. -0.26. What is the difference between the CO2 emissions (% of total fuel combustion) in 1960 and CO2 emissions (% of total fuel combustion) in 1962 in North America?
Give a very brief answer. -0.39. What is the difference between the CO2 emissions (% of total fuel combustion) in 1960 and CO2 emissions (% of total fuel combustion) in 1963 in North America?
Your answer should be compact. 0.49. What is the difference between the CO2 emissions (% of total fuel combustion) of 1961 and CO2 emissions (% of total fuel combustion) of 1962 in North America?
Provide a succinct answer. -0.14. What is the difference between the CO2 emissions (% of total fuel combustion) in 1961 and CO2 emissions (% of total fuel combustion) in 1963 in North America?
Provide a succinct answer. 0.74. What is the difference between the CO2 emissions (% of total fuel combustion) in 1962 and CO2 emissions (% of total fuel combustion) in 1963 in North America?
Offer a very short reply. 0.88. What is the ratio of the CO2 emissions (% of total fuel combustion) of 1960 in European Union to that in High income?
Provide a succinct answer. 1.11. What is the ratio of the CO2 emissions (% of total fuel combustion) in 1961 in European Union to that in High income?
Make the answer very short. 1.1. What is the ratio of the CO2 emissions (% of total fuel combustion) in 1962 in European Union to that in High income?
Provide a short and direct response. 1.12. What is the ratio of the CO2 emissions (% of total fuel combustion) of 1963 in European Union to that in High income?
Make the answer very short. 1.18. What is the ratio of the CO2 emissions (% of total fuel combustion) in 1960 in European Union to that in High income: OECD?
Provide a succinct answer. 1.11. What is the ratio of the CO2 emissions (% of total fuel combustion) of 1961 in European Union to that in High income: OECD?
Your response must be concise. 1.1. What is the ratio of the CO2 emissions (% of total fuel combustion) of 1963 in European Union to that in High income: OECD?
Your response must be concise. 1.18. What is the ratio of the CO2 emissions (% of total fuel combustion) of 1960 in European Union to that in Low & middle income?
Ensure brevity in your answer.  0.9. What is the ratio of the CO2 emissions (% of total fuel combustion) in 1961 in European Union to that in Low & middle income?
Keep it short and to the point. 0.93. What is the ratio of the CO2 emissions (% of total fuel combustion) in 1962 in European Union to that in Low & middle income?
Keep it short and to the point. 1. What is the ratio of the CO2 emissions (% of total fuel combustion) of 1963 in European Union to that in Low & middle income?
Provide a succinct answer. 0.9. What is the ratio of the CO2 emissions (% of total fuel combustion) in 1960 in European Union to that in Middle income?
Provide a succinct answer. 0.9. What is the ratio of the CO2 emissions (% of total fuel combustion) in 1961 in European Union to that in Middle income?
Provide a succinct answer. 0.93. What is the ratio of the CO2 emissions (% of total fuel combustion) in 1963 in European Union to that in Middle income?
Your response must be concise. 0.9. What is the ratio of the CO2 emissions (% of total fuel combustion) of 1960 in European Union to that in North America?
Your answer should be very brief. 1.11. What is the ratio of the CO2 emissions (% of total fuel combustion) of 1961 in European Union to that in North America?
Offer a terse response. 1.08. What is the ratio of the CO2 emissions (% of total fuel combustion) of 1962 in European Union to that in North America?
Your answer should be compact. 1.13. What is the ratio of the CO2 emissions (% of total fuel combustion) in 1963 in European Union to that in North America?
Provide a succinct answer. 1.23. What is the ratio of the CO2 emissions (% of total fuel combustion) in 1961 in High income to that in High income: OECD?
Give a very brief answer. 1. What is the ratio of the CO2 emissions (% of total fuel combustion) of 1962 in High income to that in High income: OECD?
Keep it short and to the point. 1. What is the ratio of the CO2 emissions (% of total fuel combustion) in 1963 in High income to that in High income: OECD?
Ensure brevity in your answer.  1. What is the ratio of the CO2 emissions (% of total fuel combustion) of 1960 in High income to that in Low & middle income?
Provide a short and direct response. 0.81. What is the ratio of the CO2 emissions (% of total fuel combustion) in 1961 in High income to that in Low & middle income?
Your response must be concise. 0.85. What is the ratio of the CO2 emissions (% of total fuel combustion) in 1962 in High income to that in Low & middle income?
Ensure brevity in your answer.  0.89. What is the ratio of the CO2 emissions (% of total fuel combustion) in 1963 in High income to that in Low & middle income?
Offer a very short reply. 0.76. What is the ratio of the CO2 emissions (% of total fuel combustion) of 1960 in High income to that in Middle income?
Provide a short and direct response. 0.81. What is the ratio of the CO2 emissions (% of total fuel combustion) in 1961 in High income to that in Middle income?
Keep it short and to the point. 0.85. What is the ratio of the CO2 emissions (% of total fuel combustion) in 1962 in High income to that in Middle income?
Your response must be concise. 0.89. What is the ratio of the CO2 emissions (% of total fuel combustion) in 1963 in High income to that in Middle income?
Provide a succinct answer. 0.76. What is the ratio of the CO2 emissions (% of total fuel combustion) in 1961 in High income to that in North America?
Your answer should be compact. 0.98. What is the ratio of the CO2 emissions (% of total fuel combustion) in 1962 in High income to that in North America?
Offer a terse response. 1. What is the ratio of the CO2 emissions (% of total fuel combustion) of 1963 in High income to that in North America?
Make the answer very short. 1.04. What is the ratio of the CO2 emissions (% of total fuel combustion) in 1960 in High income: OECD to that in Low & middle income?
Provide a succinct answer. 0.81. What is the ratio of the CO2 emissions (% of total fuel combustion) of 1961 in High income: OECD to that in Low & middle income?
Your response must be concise. 0.85. What is the ratio of the CO2 emissions (% of total fuel combustion) in 1962 in High income: OECD to that in Low & middle income?
Offer a very short reply. 0.89. What is the ratio of the CO2 emissions (% of total fuel combustion) in 1963 in High income: OECD to that in Low & middle income?
Your response must be concise. 0.76. What is the ratio of the CO2 emissions (% of total fuel combustion) of 1960 in High income: OECD to that in Middle income?
Your response must be concise. 0.81. What is the ratio of the CO2 emissions (% of total fuel combustion) in 1961 in High income: OECD to that in Middle income?
Offer a very short reply. 0.85. What is the ratio of the CO2 emissions (% of total fuel combustion) of 1962 in High income: OECD to that in Middle income?
Offer a terse response. 0.89. What is the ratio of the CO2 emissions (% of total fuel combustion) of 1963 in High income: OECD to that in Middle income?
Keep it short and to the point. 0.76. What is the ratio of the CO2 emissions (% of total fuel combustion) in 1960 in High income: OECD to that in North America?
Ensure brevity in your answer.  1. What is the ratio of the CO2 emissions (% of total fuel combustion) of 1961 in High income: OECD to that in North America?
Ensure brevity in your answer.  0.98. What is the ratio of the CO2 emissions (% of total fuel combustion) of 1963 in High income: OECD to that in North America?
Provide a succinct answer. 1.04. What is the ratio of the CO2 emissions (% of total fuel combustion) in 1960 in Low & middle income to that in Middle income?
Ensure brevity in your answer.  1. What is the ratio of the CO2 emissions (% of total fuel combustion) of 1962 in Low & middle income to that in Middle income?
Keep it short and to the point. 1. What is the ratio of the CO2 emissions (% of total fuel combustion) of 1960 in Low & middle income to that in North America?
Provide a short and direct response. 1.23. What is the ratio of the CO2 emissions (% of total fuel combustion) in 1961 in Low & middle income to that in North America?
Your response must be concise. 1.15. What is the ratio of the CO2 emissions (% of total fuel combustion) in 1962 in Low & middle income to that in North America?
Your response must be concise. 1.12. What is the ratio of the CO2 emissions (% of total fuel combustion) of 1963 in Low & middle income to that in North America?
Your response must be concise. 1.37. What is the ratio of the CO2 emissions (% of total fuel combustion) in 1960 in Middle income to that in North America?
Your answer should be very brief. 1.23. What is the ratio of the CO2 emissions (% of total fuel combustion) in 1961 in Middle income to that in North America?
Offer a terse response. 1.15. What is the ratio of the CO2 emissions (% of total fuel combustion) in 1962 in Middle income to that in North America?
Make the answer very short. 1.12. What is the ratio of the CO2 emissions (% of total fuel combustion) of 1963 in Middle income to that in North America?
Provide a succinct answer. 1.37. What is the difference between the highest and the second highest CO2 emissions (% of total fuel combustion) of 1961?
Provide a succinct answer. 0. What is the difference between the highest and the second highest CO2 emissions (% of total fuel combustion) of 1962?
Make the answer very short. 0.06. What is the difference between the highest and the second highest CO2 emissions (% of total fuel combustion) of 1963?
Ensure brevity in your answer.  0. What is the difference between the highest and the lowest CO2 emissions (% of total fuel combustion) of 1960?
Give a very brief answer. 4.74. What is the difference between the highest and the lowest CO2 emissions (% of total fuel combustion) of 1961?
Make the answer very short. 3.52. What is the difference between the highest and the lowest CO2 emissions (% of total fuel combustion) in 1962?
Keep it short and to the point. 2.61. What is the difference between the highest and the lowest CO2 emissions (% of total fuel combustion) in 1963?
Offer a terse response. 7.27. 